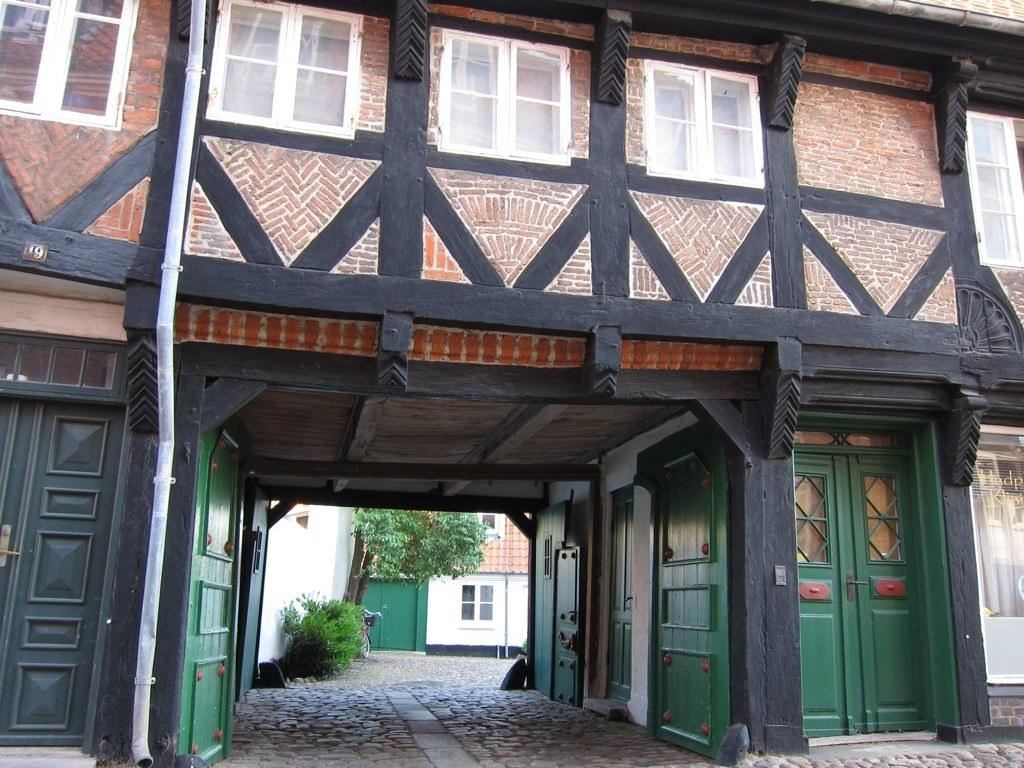What type of structure is present in the image? There is a building in the picture. What features can be observed on the building? The building has windows and doors. Is there any infrastructure associated with the building? Yes, there is a pipe associated with the building. What can be seen in the background of the image? Plants, trees, and a bicycle are visible behind the building. What type of area might this image depict? The scene looks like a residential area. How many cows are visible in the image? There are no cows present in the image. What type of care is being provided to the cows in the image? There are no cows present in the image, so no care is being provided. 